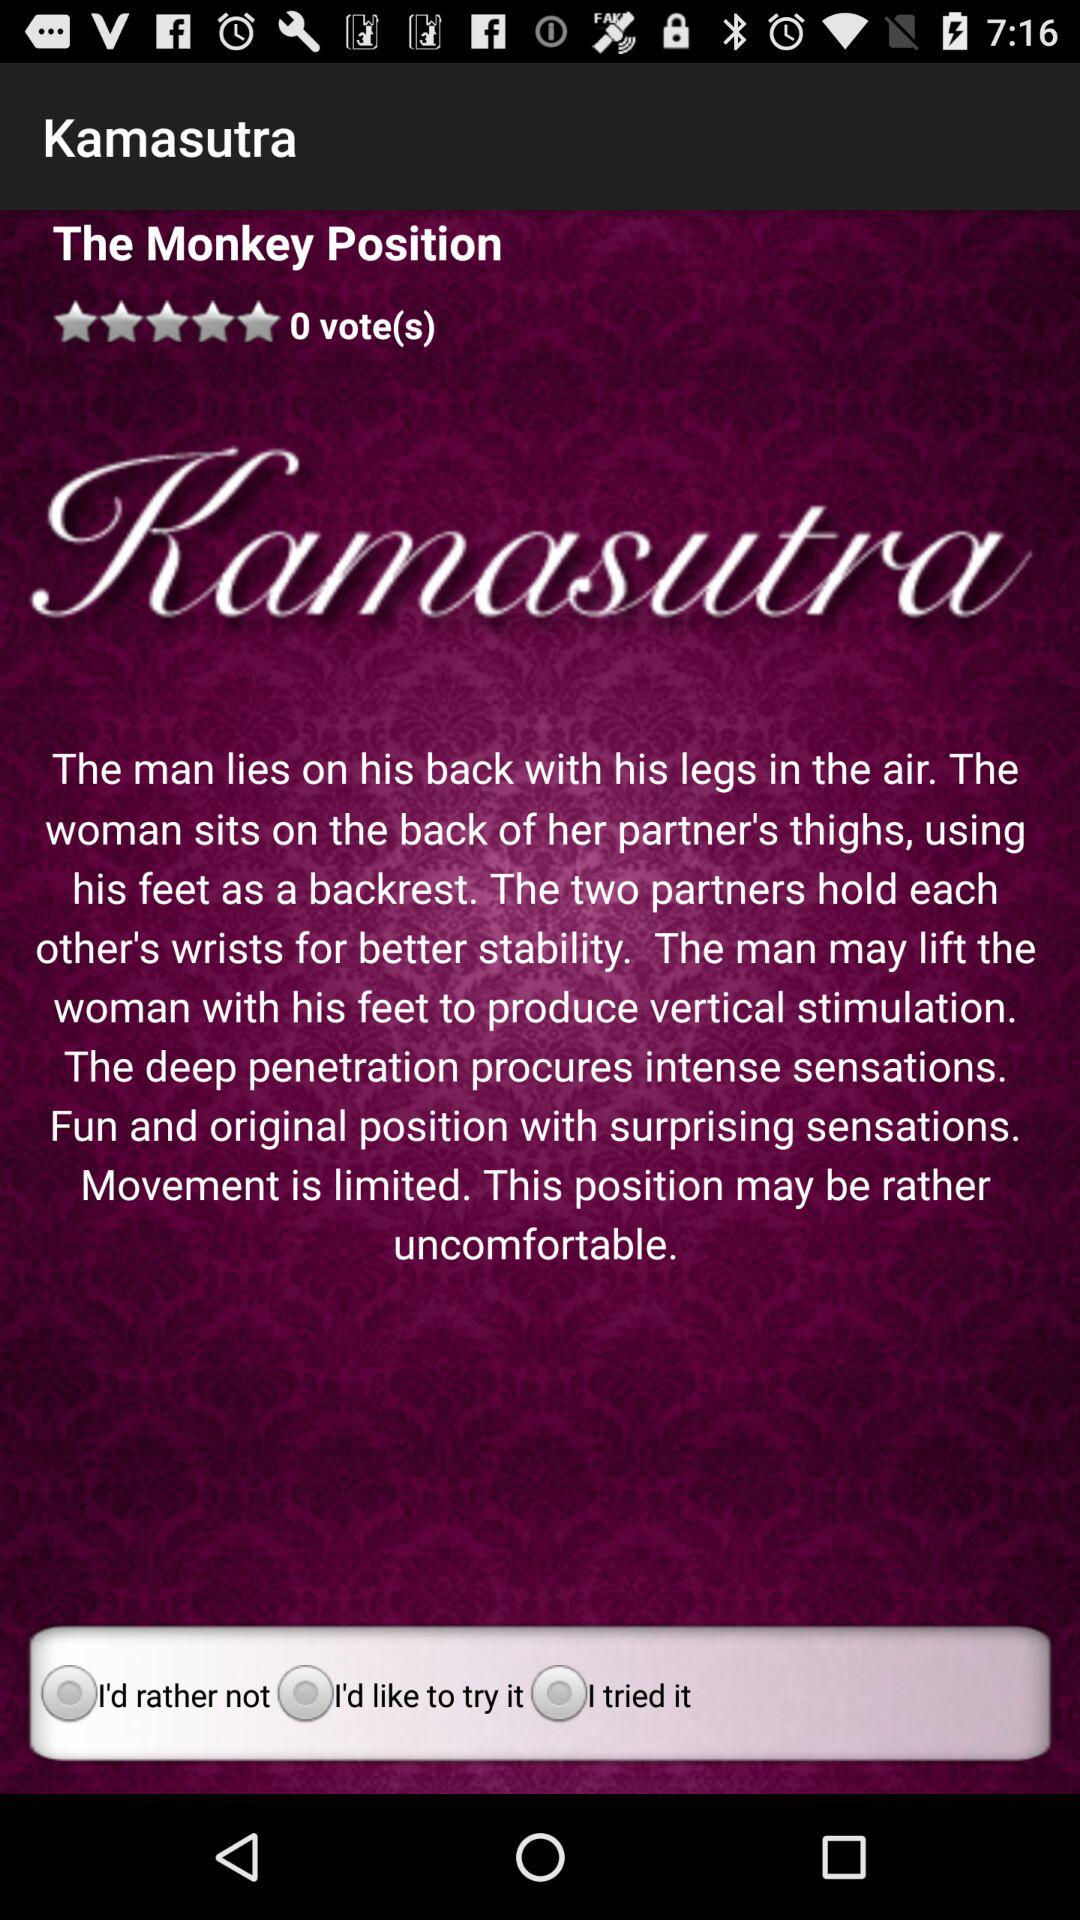How many votes does it get? It gets 0 votes. 